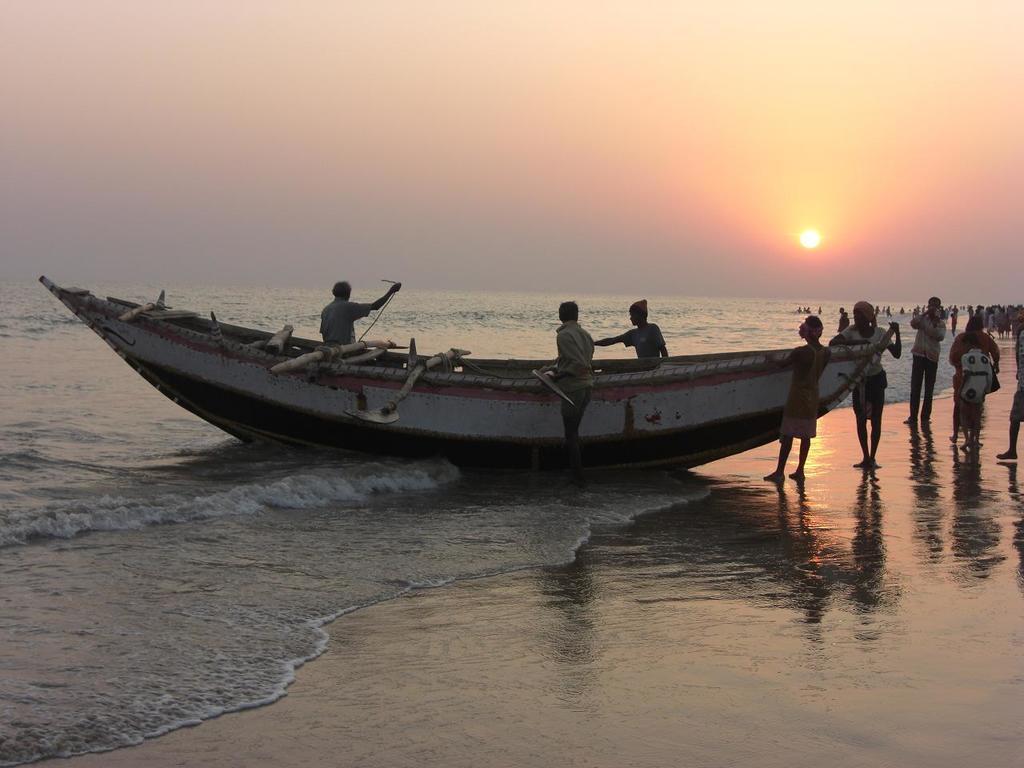Could you give a brief overview of what you see in this image? In the picture we can see the boat near the ocean, in the boat we can see three people are sitting and near it we can see some people are standing and in the background we can see the water surface and behind it we can see the sky with sun. 